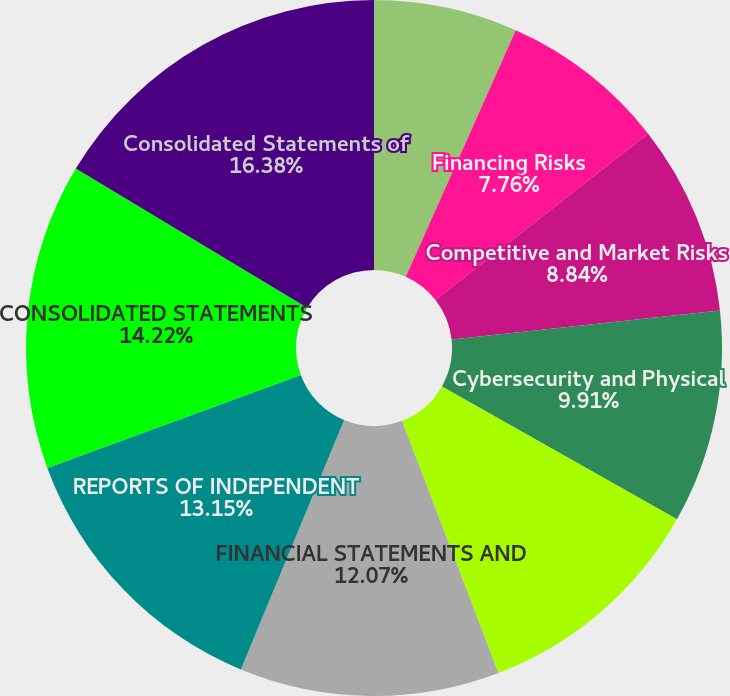Convert chart to OTSL. <chart><loc_0><loc_0><loc_500><loc_500><pie_chart><fcel>Operating Risks<fcel>Financing Risks<fcel>Competitive and Market Risks<fcel>Cybersecurity and Physical<fcel>QUANTITATIVE AND QUALITATIVE<fcel>FINANCIAL STATEMENTS AND<fcel>REPORTS OF INDEPENDENT<fcel>CONSOLIDATED STATEMENTS<fcel>Consolidated Statements of<nl><fcel>6.68%<fcel>7.76%<fcel>8.84%<fcel>9.91%<fcel>10.99%<fcel>12.07%<fcel>13.15%<fcel>14.22%<fcel>16.38%<nl></chart> 